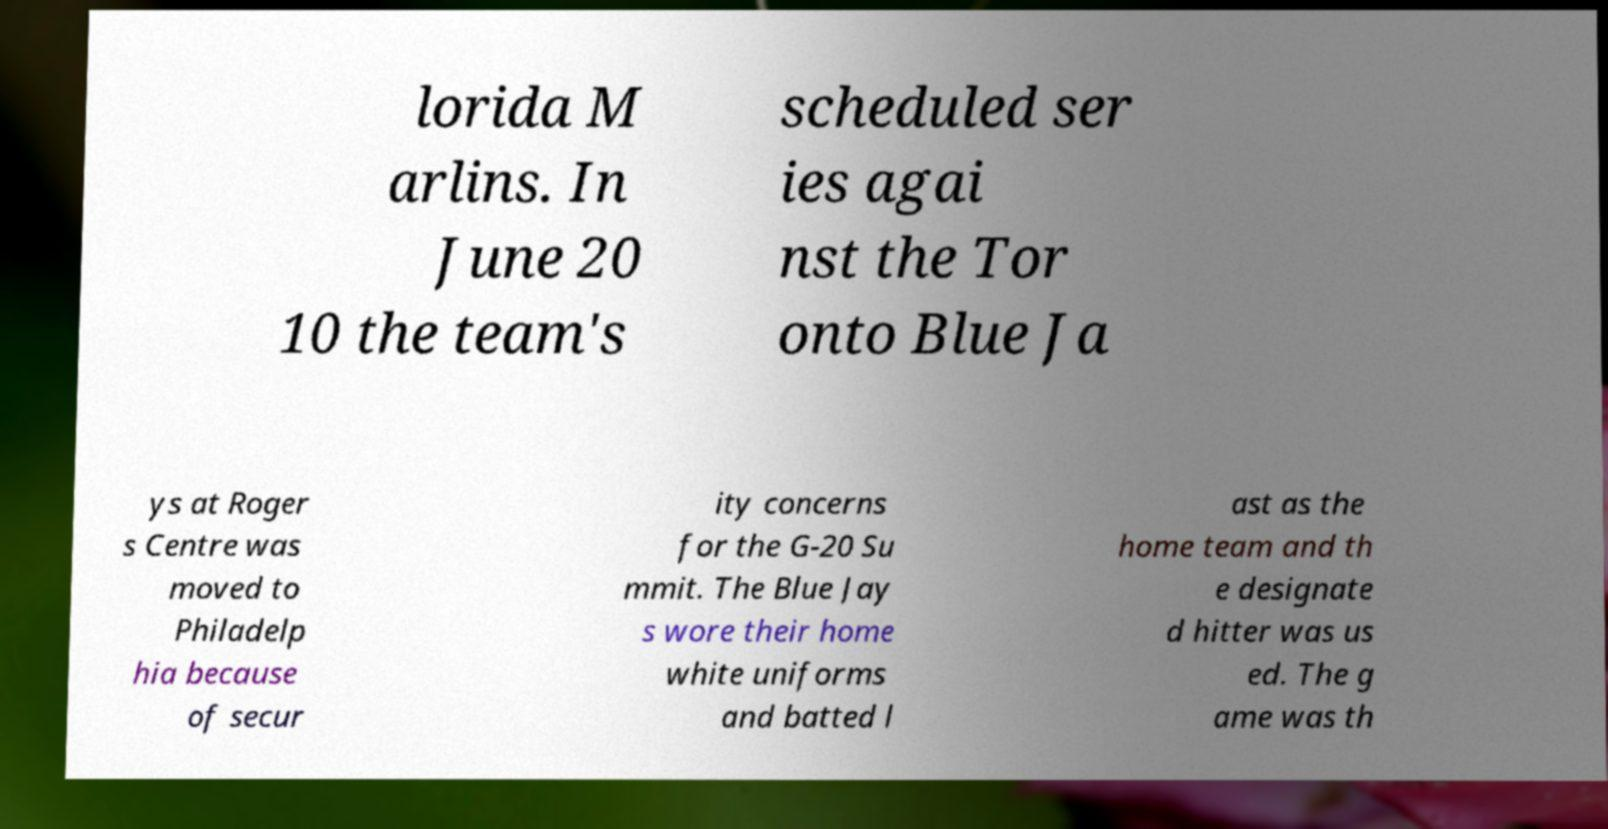Can you accurately transcribe the text from the provided image for me? lorida M arlins. In June 20 10 the team's scheduled ser ies agai nst the Tor onto Blue Ja ys at Roger s Centre was moved to Philadelp hia because of secur ity concerns for the G-20 Su mmit. The Blue Jay s wore their home white uniforms and batted l ast as the home team and th e designate d hitter was us ed. The g ame was th 